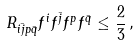<formula> <loc_0><loc_0><loc_500><loc_500>R _ { i \bar { j } p \bar { q } } f ^ { i } f ^ { \bar { j } } f ^ { p } f ^ { \bar { q } } \leq \frac { 2 } { 3 } \, ,</formula> 